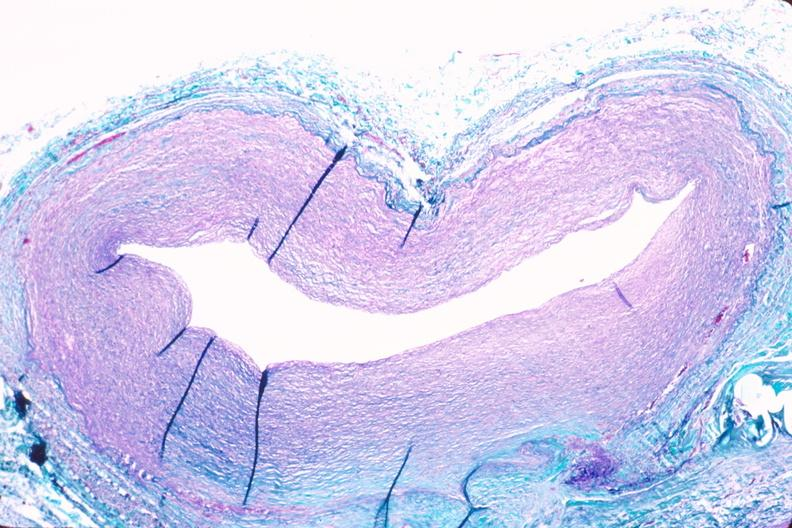does intraductal papillomatosis with apocrine metaplasia show saphenous vein graft sclerosis?
Answer the question using a single word or phrase. No 